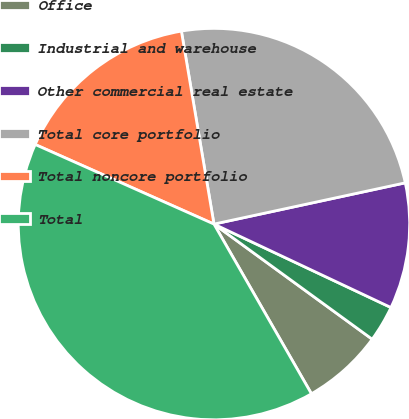Convert chart to OTSL. <chart><loc_0><loc_0><loc_500><loc_500><pie_chart><fcel>Office<fcel>Industrial and warehouse<fcel>Other commercial real estate<fcel>Total core portfolio<fcel>Total noncore portfolio<fcel>Total<nl><fcel>6.69%<fcel>3.0%<fcel>10.39%<fcel>24.28%<fcel>15.67%<fcel>39.96%<nl></chart> 